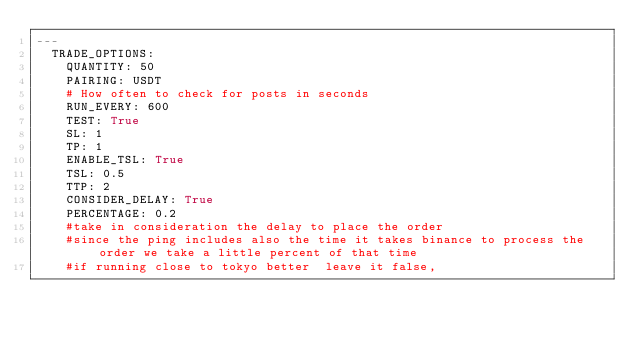<code> <loc_0><loc_0><loc_500><loc_500><_YAML_>---
  TRADE_OPTIONS:
    QUANTITY: 50
    PAIRING: USDT
    # How often to check for posts in seconds
    RUN_EVERY: 600
    TEST: True
    SL: 1
    TP: 1
    ENABLE_TSL: True
    TSL: 0.5
    TTP: 2
    CONSIDER_DELAY: True
    PERCENTAGE: 0.2
    #take in consideration the delay to place the order
    #since the ping includes also the time it takes binance to process the order we take a little percent of that time
    #if running close to tokyo better  leave it false,
</code> 